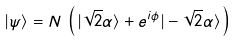Convert formula to latex. <formula><loc_0><loc_0><loc_500><loc_500>| \psi \rangle = N \, \left ( \, | \sqrt { 2 } \alpha \rangle + e ^ { i \phi } | - \sqrt { 2 } \alpha \rangle \, \right )</formula> 